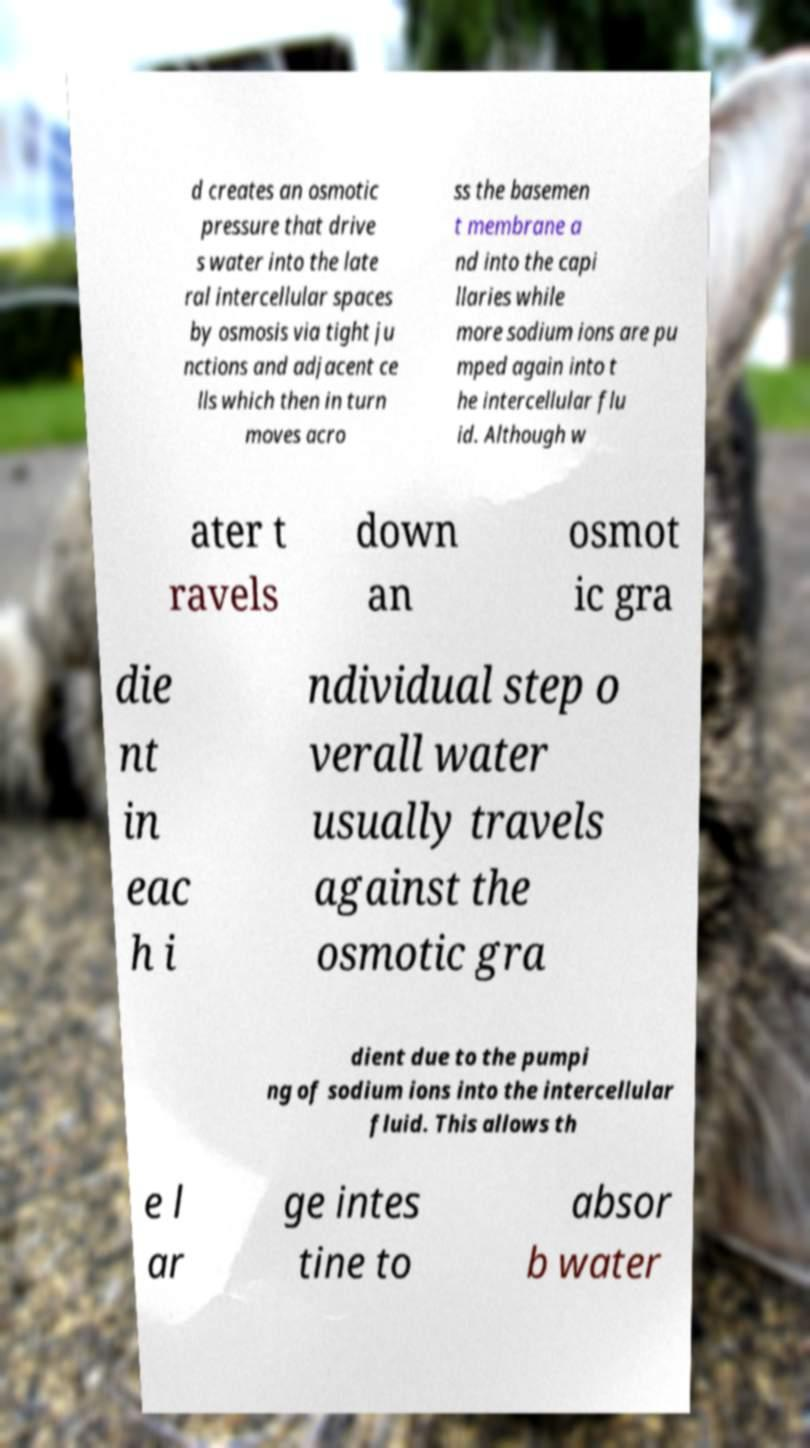Can you accurately transcribe the text from the provided image for me? d creates an osmotic pressure that drive s water into the late ral intercellular spaces by osmosis via tight ju nctions and adjacent ce lls which then in turn moves acro ss the basemen t membrane a nd into the capi llaries while more sodium ions are pu mped again into t he intercellular flu id. Although w ater t ravels down an osmot ic gra die nt in eac h i ndividual step o verall water usually travels against the osmotic gra dient due to the pumpi ng of sodium ions into the intercellular fluid. This allows th e l ar ge intes tine to absor b water 